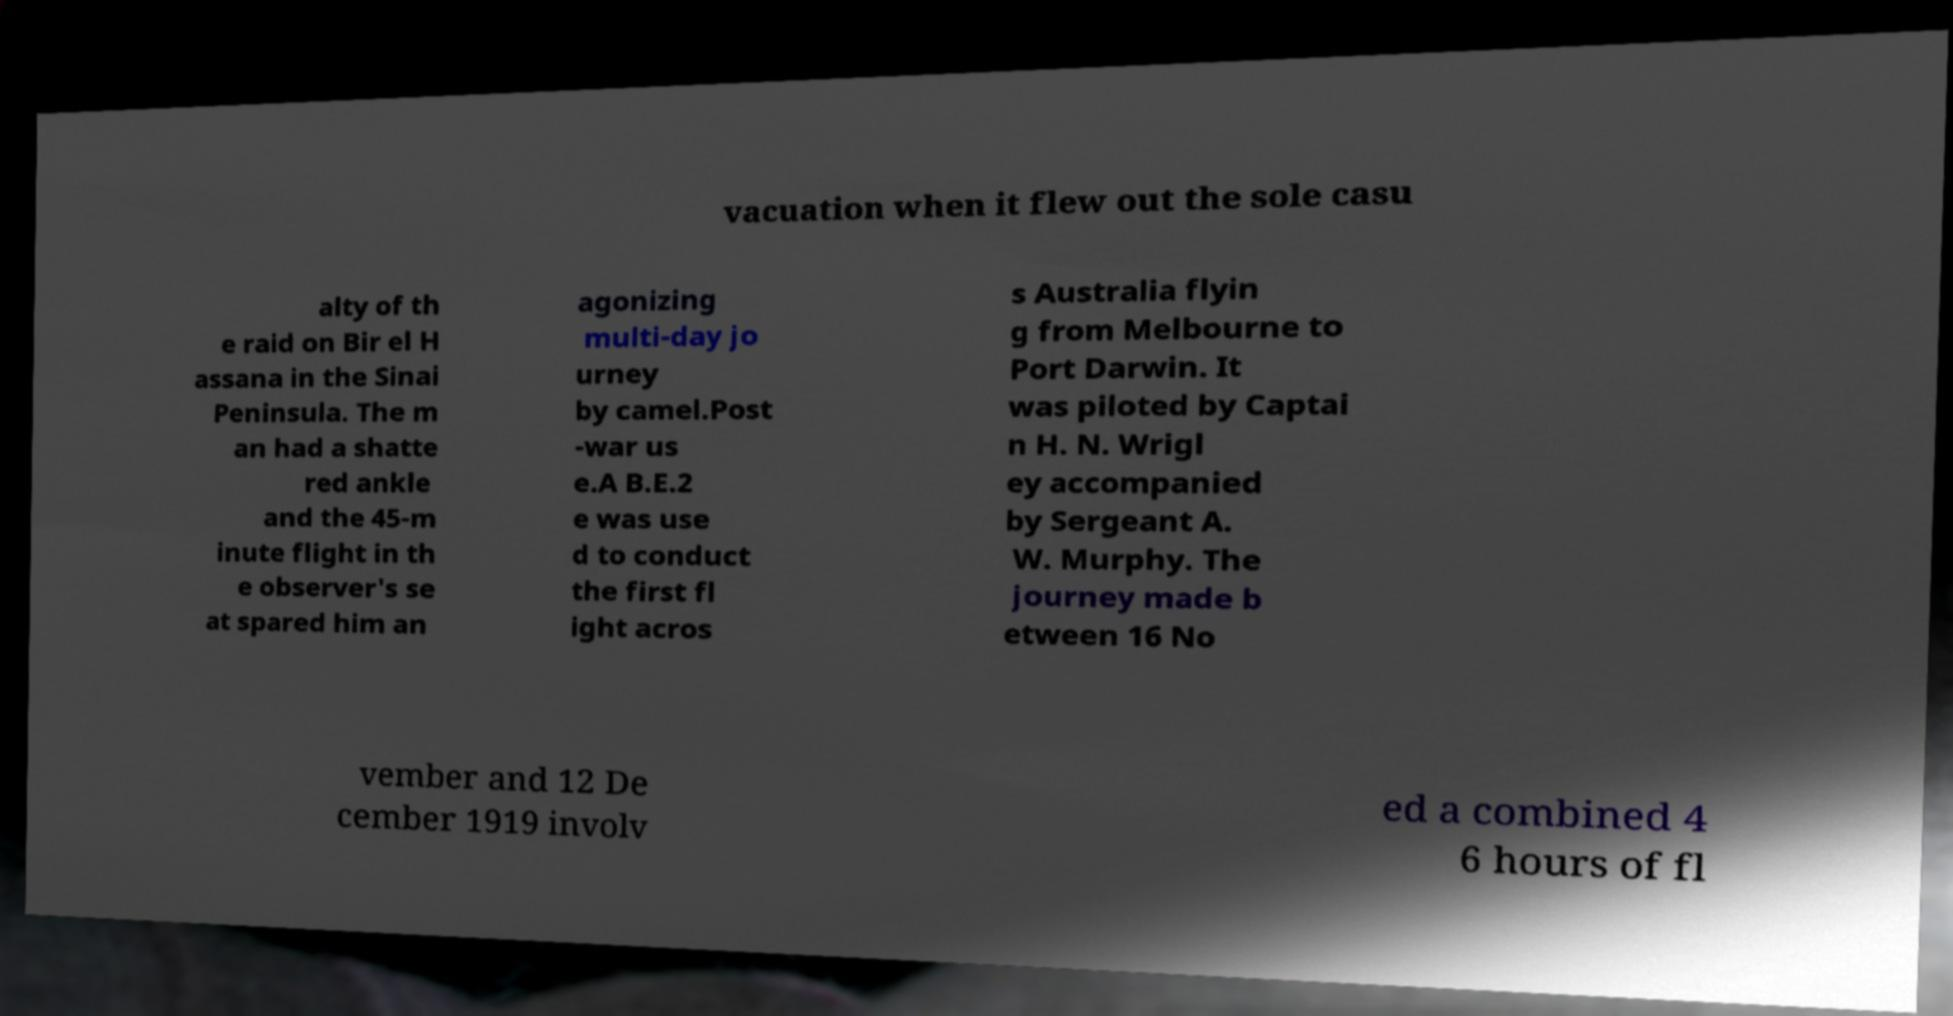Can you accurately transcribe the text from the provided image for me? vacuation when it flew out the sole casu alty of th e raid on Bir el H assana in the Sinai Peninsula. The m an had a shatte red ankle and the 45-m inute flight in th e observer's se at spared him an agonizing multi-day jo urney by camel.Post -war us e.A B.E.2 e was use d to conduct the first fl ight acros s Australia flyin g from Melbourne to Port Darwin. It was piloted by Captai n H. N. Wrigl ey accompanied by Sergeant A. W. Murphy. The journey made b etween 16 No vember and 12 De cember 1919 involv ed a combined 4 6 hours of fl 